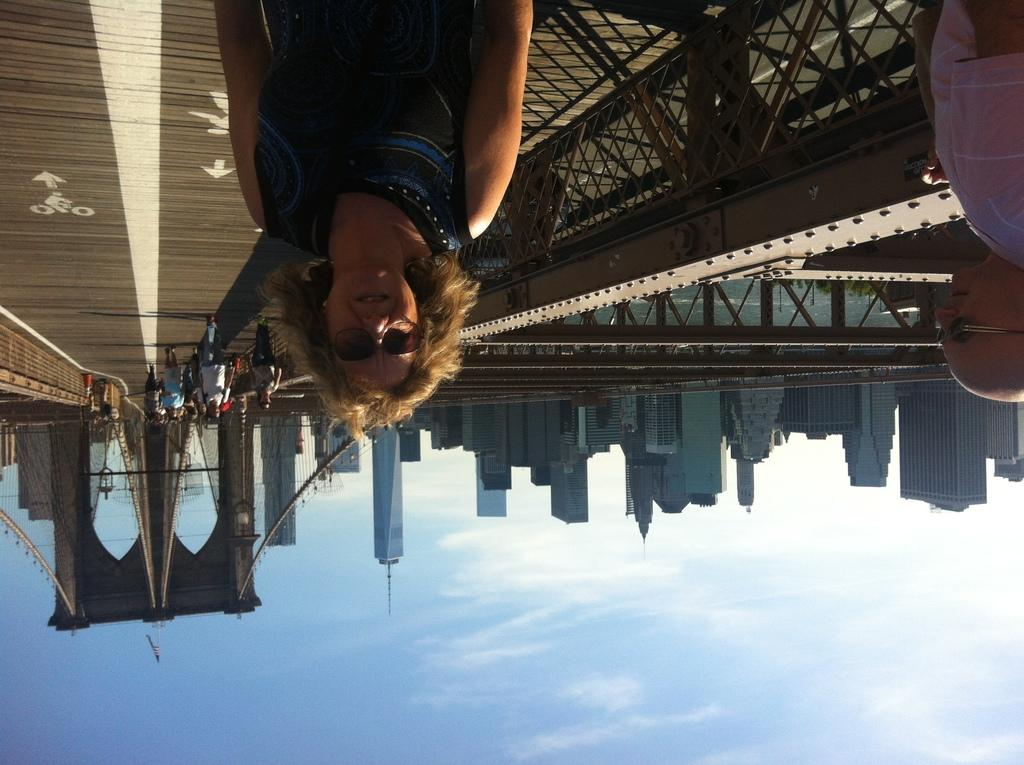Who or what can be seen in the image? There are people in the image. What type of structures are present in the image? There are buildings in the image. What architectural feature is visible in the image? There are arches in the image. What can be used for transportation in the image? There is a road in the image. What is visible above the structures and people? The sky is visible in the image. What type of book is being read by the person wearing a crown in the image? There is no person wearing a crown or reading a book in the image. What type of shake is being offered to the person in the image? There is no shake being offered in the image. 